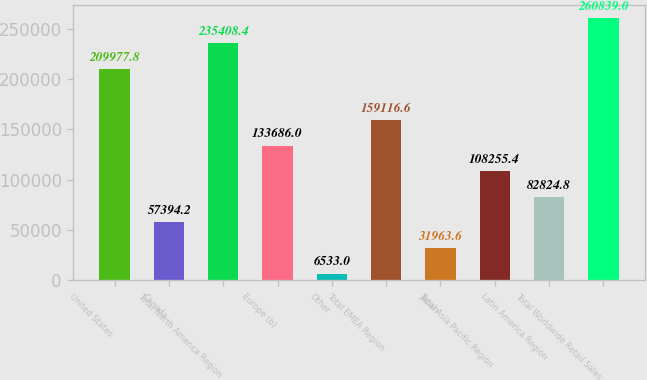Convert chart to OTSL. <chart><loc_0><loc_0><loc_500><loc_500><bar_chart><fcel>United States<fcel>Canada<fcel>Total North America Region<fcel>Europe (b)<fcel>Other<fcel>Total EMEA Region<fcel>Japan<fcel>Total Asia Pacific Region<fcel>Latin America Region<fcel>Total Worldwide Retail Sales<nl><fcel>209978<fcel>57394.2<fcel>235408<fcel>133686<fcel>6533<fcel>159117<fcel>31963.6<fcel>108255<fcel>82824.8<fcel>260839<nl></chart> 